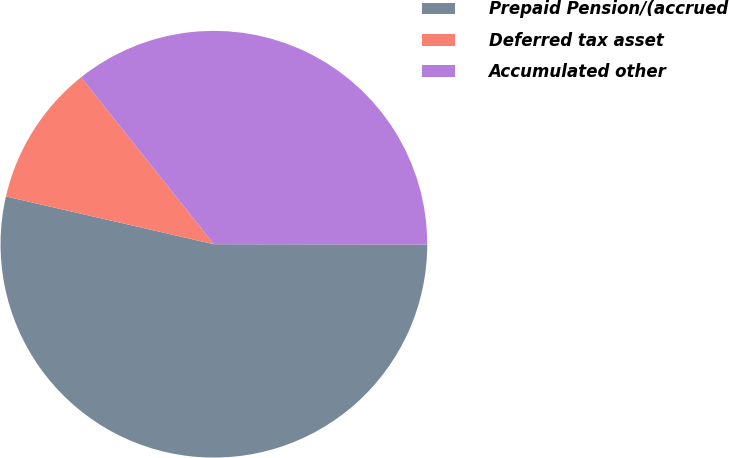Convert chart to OTSL. <chart><loc_0><loc_0><loc_500><loc_500><pie_chart><fcel>Prepaid Pension/(accrued<fcel>Deferred tax asset<fcel>Accumulated other<nl><fcel>53.57%<fcel>10.71%<fcel>35.71%<nl></chart> 